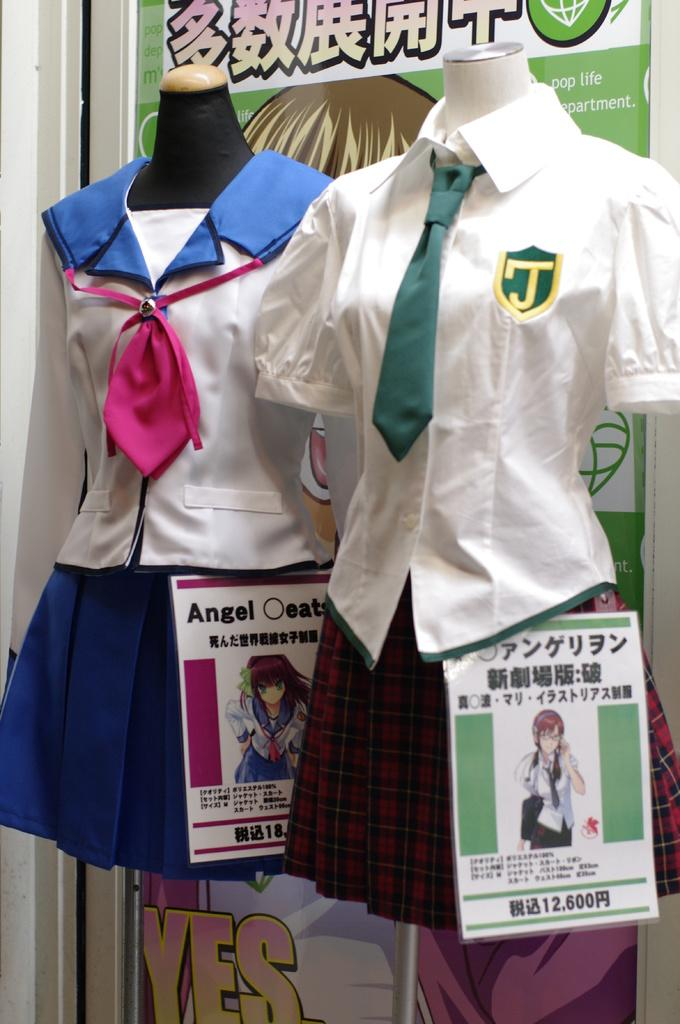How many uniforms can be seen in the image? There are two different uniforms in the image. What colors are featured in the first uniform? The first uniform is in white and red color. What colors are featured in the second uniform? The second uniform is in white and blue color. What additional element can be seen in the image? There is a banner in the image. What song is being sung by the people wearing the uniforms in the image? There is no indication of a song being sung in the image, as it only shows the uniforms and a banner. 